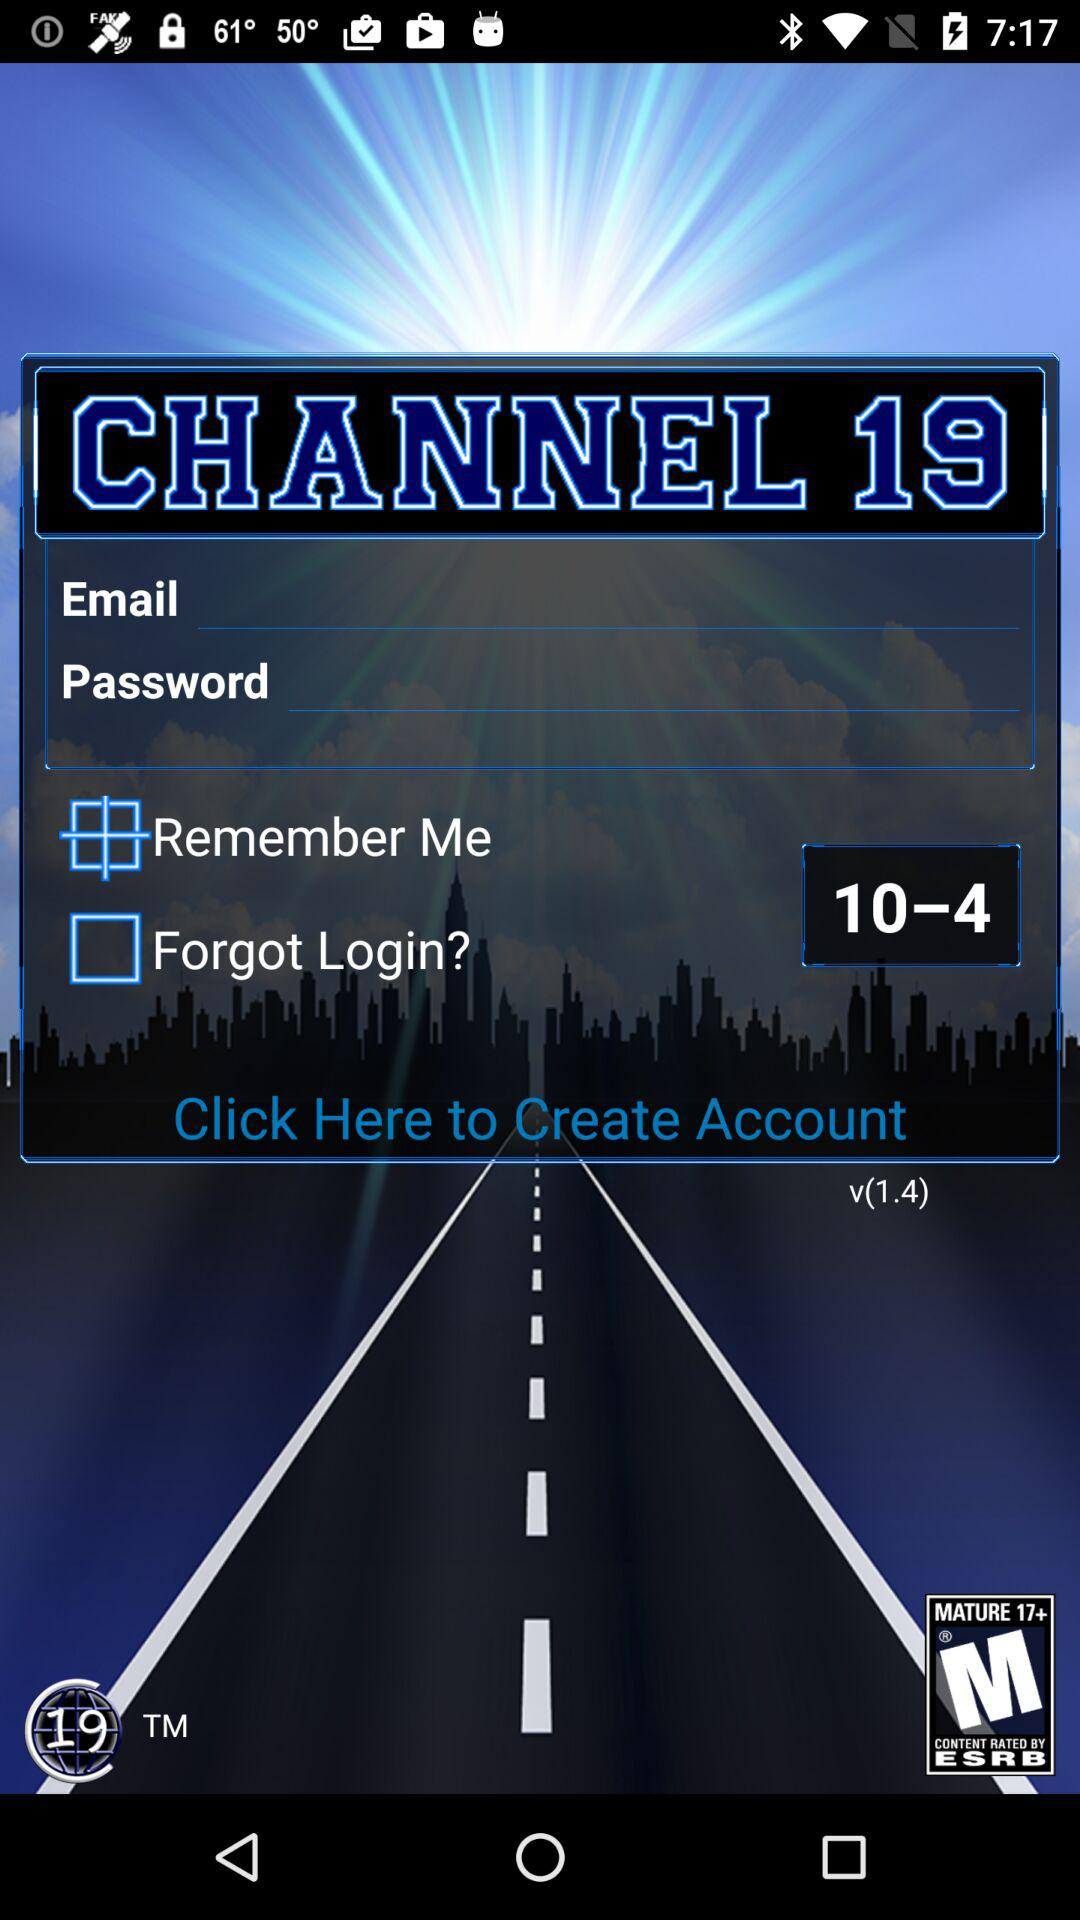What is the application name? The application name is "CHANNEL 19". 